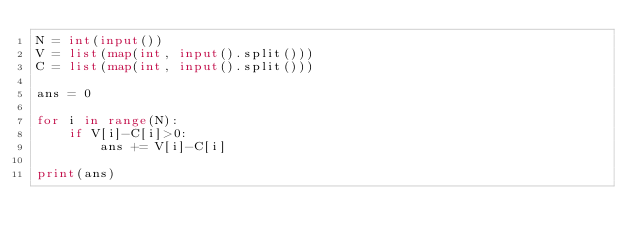Convert code to text. <code><loc_0><loc_0><loc_500><loc_500><_Python_>N = int(input())
V = list(map(int, input().split()))
C = list(map(int, input().split()))

ans = 0

for i in range(N):
    if V[i]-C[i]>0:
        ans += V[i]-C[i]

print(ans)</code> 